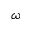Convert formula to latex. <formula><loc_0><loc_0><loc_500><loc_500>\omega</formula> 